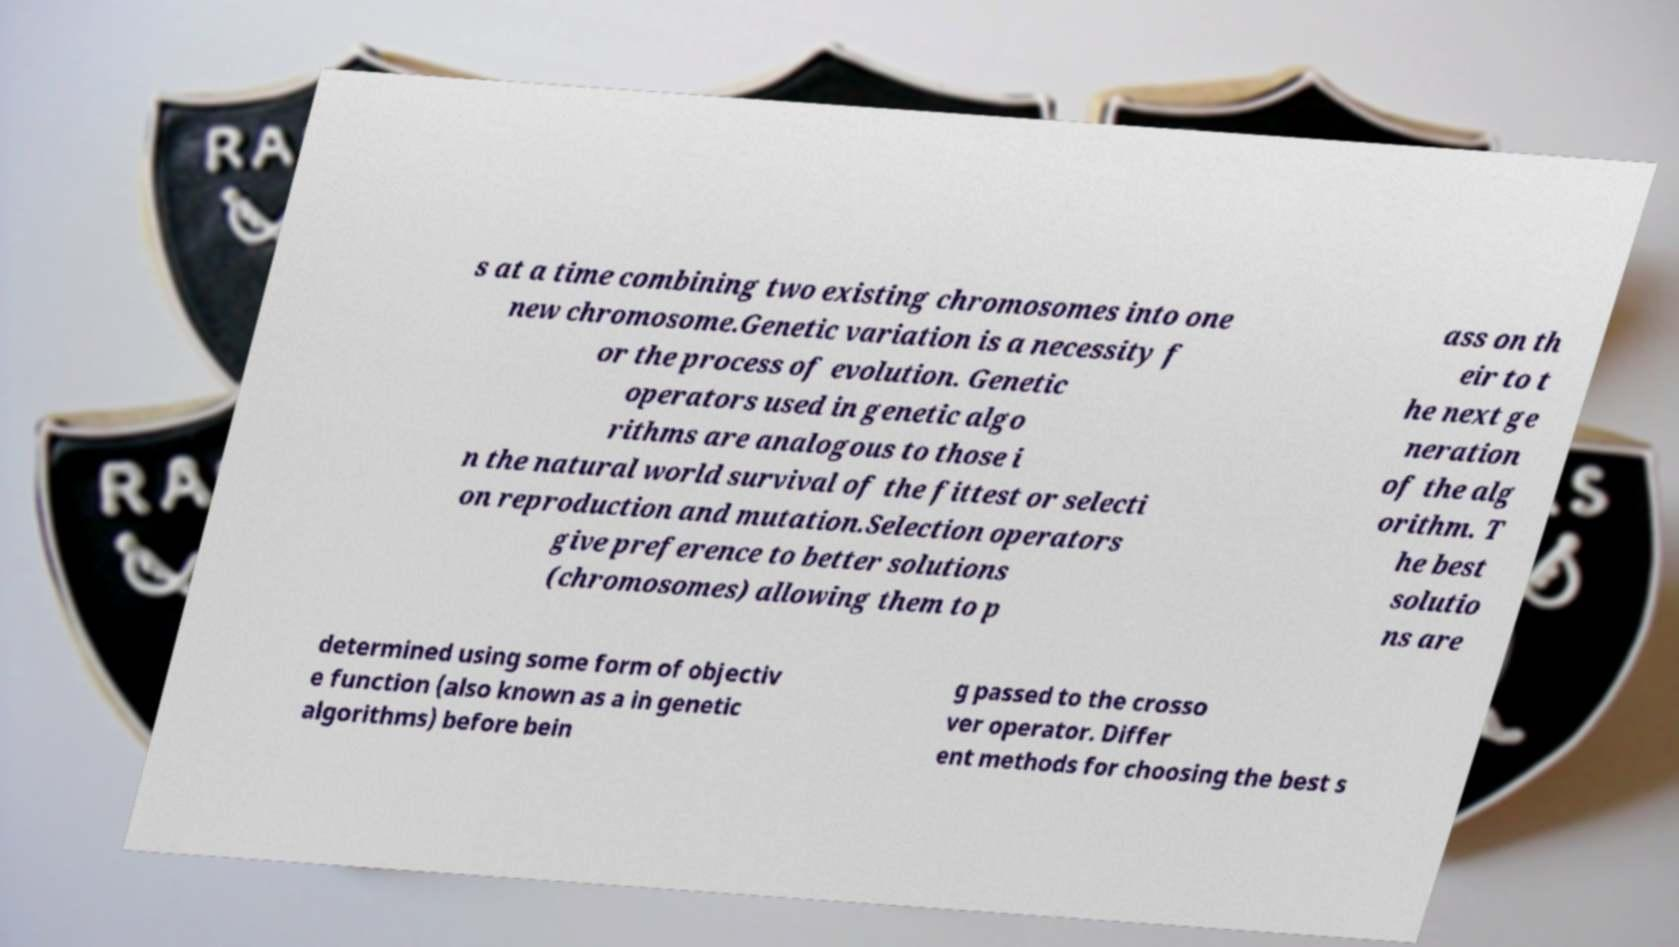Please read and relay the text visible in this image. What does it say? s at a time combining two existing chromosomes into one new chromosome.Genetic variation is a necessity f or the process of evolution. Genetic operators used in genetic algo rithms are analogous to those i n the natural world survival of the fittest or selecti on reproduction and mutation.Selection operators give preference to better solutions (chromosomes) allowing them to p ass on th eir to t he next ge neration of the alg orithm. T he best solutio ns are determined using some form of objectiv e function (also known as a in genetic algorithms) before bein g passed to the crosso ver operator. Differ ent methods for choosing the best s 